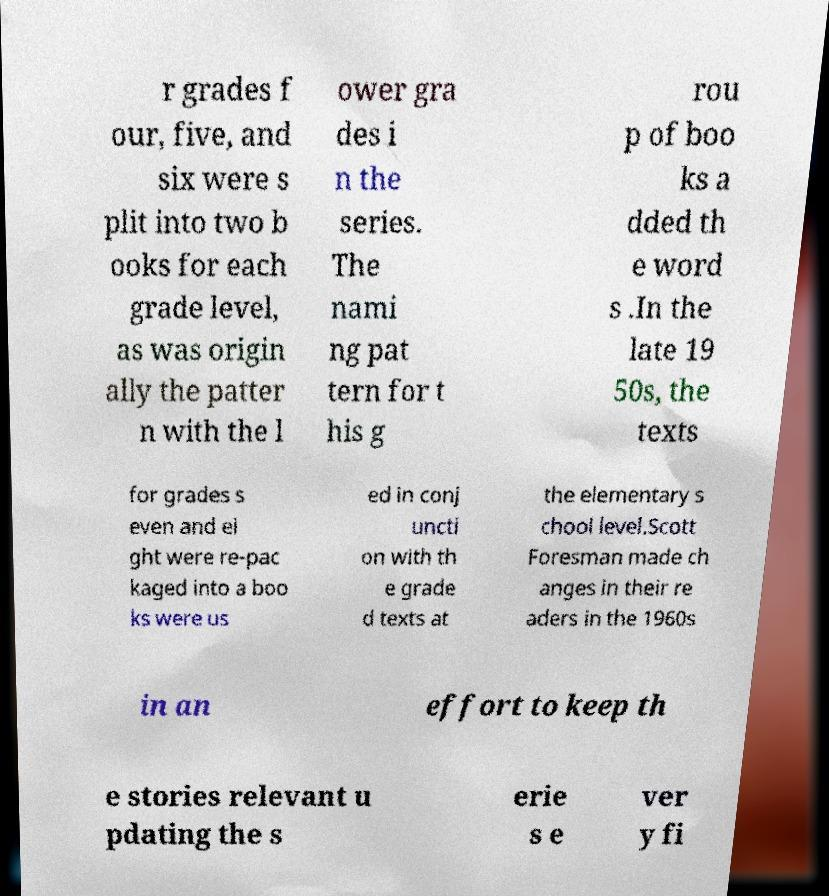Please identify and transcribe the text found in this image. r grades f our, five, and six were s plit into two b ooks for each grade level, as was origin ally the patter n with the l ower gra des i n the series. The nami ng pat tern for t his g rou p of boo ks a dded th e word s .In the late 19 50s, the texts for grades s even and ei ght were re-pac kaged into a boo ks were us ed in conj uncti on with th e grade d texts at the elementary s chool level.Scott Foresman made ch anges in their re aders in the 1960s in an effort to keep th e stories relevant u pdating the s erie s e ver y fi 